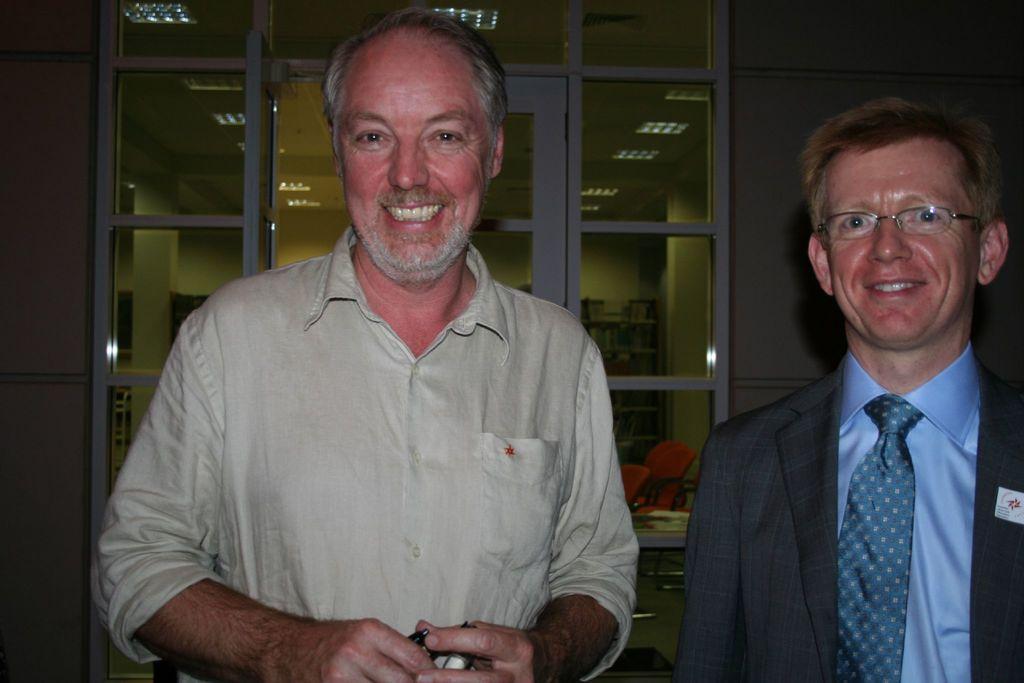Describe this image in one or two sentences. In this image I can see two people standing and posing for the picture. I can see a glass door which is see through behind them. I can see some chairs and a table. I can see some books after the glass. 